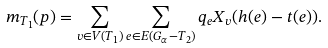Convert formula to latex. <formula><loc_0><loc_0><loc_500><loc_500>m _ { T _ { 1 } } ( p ) = \sum _ { v \in V ( T _ { 1 } ) } \sum _ { e \in E ( G _ { \alpha } - T _ { 2 } ) } q _ { e } X _ { v } ( h ( e ) - t ( e ) ) .</formula> 